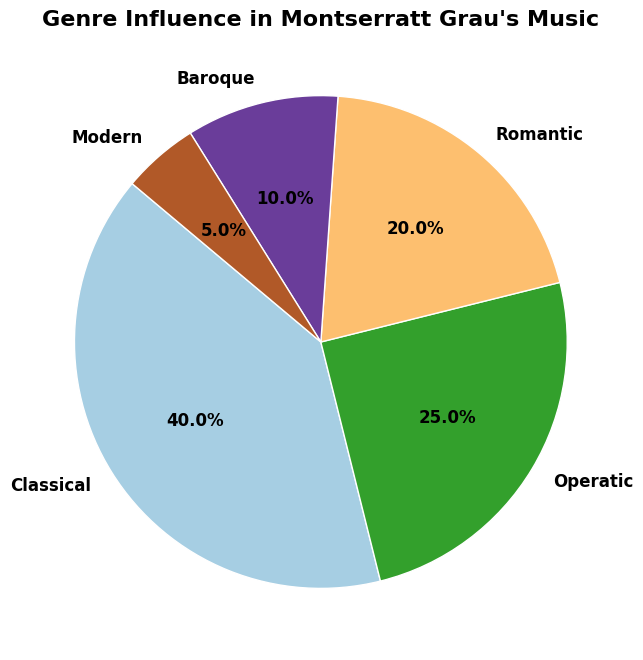What genre has the highest influence percentage in Montserratt Grau's music? The slice labeled "Classical" covers the largest area in the pie chart, indicating it has the highest influence percentage among all the genres listed.
Answer: Classical Which genre has the lowest influence percentage? The smallest slice in the pie chart is labeled "Modern," pointing out that it has the least influence percentage among the genres.
Answer: Modern How many genres have an influence percentage greater than 20%? The slices labeled "Classical" (40%) and "Operatic" (25%) have influence percentages greater than 20%. These are the only two genres that meet the criteria.
Answer: 2 What is the combined influence percentage of the Romantic and Baroque genres in Montserratt Grau's music? The Romantic genre has a 20% influence, and the Baroque genre has a 10% influence. Combining them means adding these two percentages: 20% + 10% = 30%.
Answer: 30% How does the influence of the Classical genre compare to the sum of the Modern, Baroque, and Romantic genres' influence percentages? The Classical genre's influence is 40%. Adding the influence percentages of Modern, Baroque, and Romantic genres gives 5% + 10% + 20% = 35%. Therefore, the Classical genre has a greater influence than the sum of the Modern, Baroque, and Romantic genres.
Answer: Greater Which genres together account for half of the overall influence percentage? The Classical genre alone is 40%. Adding the Operatic genre's 25% gives 65%, which exceeds half. However, the Classical (40%) and Romantic (20%) together sum to 60%, still exceeding half. Therefore, the closest pair under half are the Classical (40%) and Operatic (25%) which sum to 65%.
Answer: Classical and Operatic What is the average influence percentage of all the genres listed? Adding all the influence percentages: 40% (Classical) + 25% (Operatic) + 20% (Romantic) + 10% (Baroque) + 5% (Modern) = 100%. Since there are 5 genres, the average is 100% / 5 = 20%.
Answer: 20% How much lesser is the Modern genre's influence compared to the Classical genre's influence? The influence percentage of the Classical genre is 40%, while the Modern genre is 5%. The difference between them is: 40% - 5% = 35%. Therefore, the Modern genre's influence is 35 percentage points less than the Classical genre's.
Answer: 35% Which genre segment appears to cover 1/4th of the entire pie chart? The genre segment for "Operatic" has a 25% influence, which exactly represents 1/4th (25%) of 100%, therefore covering 1/4th of the pie chart.
Answer: Operatic 